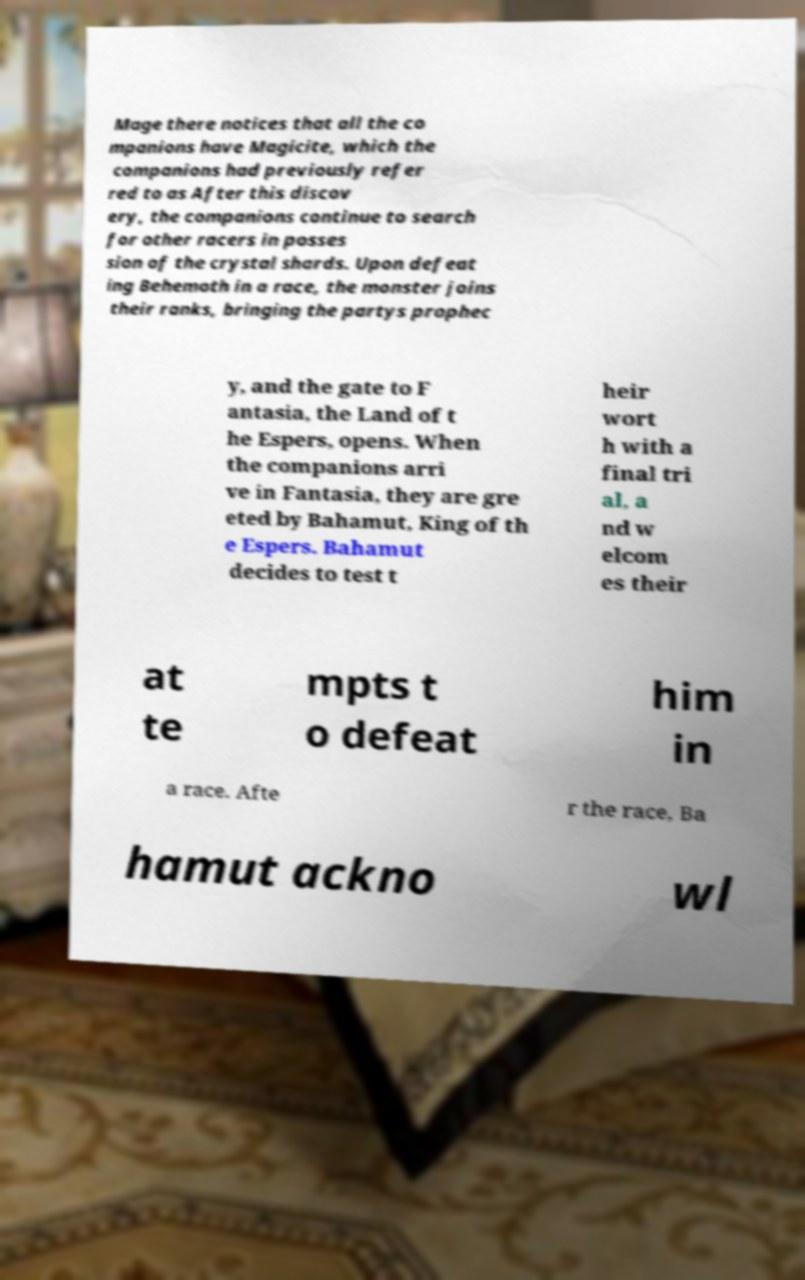Can you read and provide the text displayed in the image?This photo seems to have some interesting text. Can you extract and type it out for me? Mage there notices that all the co mpanions have Magicite, which the companions had previously refer red to as After this discov ery, the companions continue to search for other racers in posses sion of the crystal shards. Upon defeat ing Behemoth in a race, the monster joins their ranks, bringing the partys prophec y, and the gate to F antasia, the Land of t he Espers, opens. When the companions arri ve in Fantasia, they are gre eted by Bahamut, King of th e Espers. Bahamut decides to test t heir wort h with a final tri al, a nd w elcom es their at te mpts t o defeat him in a race. Afte r the race, Ba hamut ackno wl 